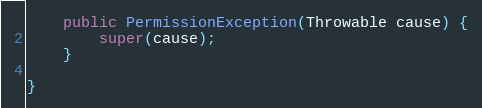Convert code to text. <code><loc_0><loc_0><loc_500><loc_500><_Java_>	public PermissionException(Throwable cause) {
		super(cause);
	}

}
</code> 